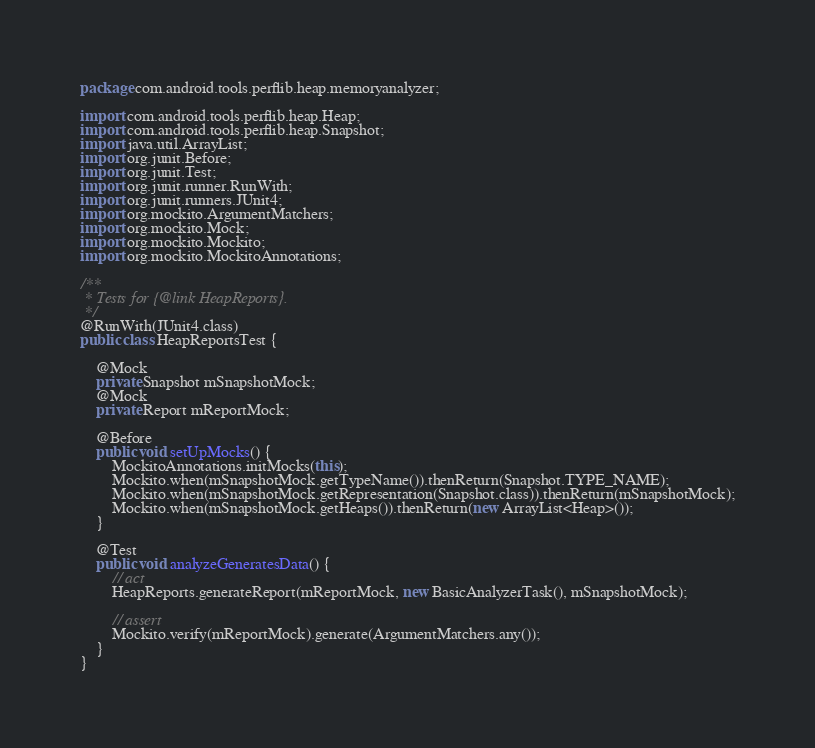Convert code to text. <code><loc_0><loc_0><loc_500><loc_500><_Java_>package com.android.tools.perflib.heap.memoryanalyzer;

import com.android.tools.perflib.heap.Heap;
import com.android.tools.perflib.heap.Snapshot;
import java.util.ArrayList;
import org.junit.Before;
import org.junit.Test;
import org.junit.runner.RunWith;
import org.junit.runners.JUnit4;
import org.mockito.ArgumentMatchers;
import org.mockito.Mock;
import org.mockito.Mockito;
import org.mockito.MockitoAnnotations;

/**
 * Tests for {@link HeapReports}.
 */
@RunWith(JUnit4.class)
public class HeapReportsTest {

    @Mock
    private Snapshot mSnapshotMock;
    @Mock
    private Report mReportMock;

    @Before
    public void setUpMocks() {
        MockitoAnnotations.initMocks(this);
        Mockito.when(mSnapshotMock.getTypeName()).thenReturn(Snapshot.TYPE_NAME);
        Mockito.when(mSnapshotMock.getRepresentation(Snapshot.class)).thenReturn(mSnapshotMock);
        Mockito.when(mSnapshotMock.getHeaps()).thenReturn(new ArrayList<Heap>());
    }

    @Test
    public void analyzeGeneratesData() {
        // act
        HeapReports.generateReport(mReportMock, new BasicAnalyzerTask(), mSnapshotMock);

        // assert
        Mockito.verify(mReportMock).generate(ArgumentMatchers.any());
    }
}
</code> 